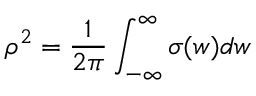Convert formula to latex. <formula><loc_0><loc_0><loc_500><loc_500>\rho ^ { 2 } = \frac { 1 } { 2 \pi } \int _ { - \infty } ^ { \infty } \sigma ( w ) d w</formula> 